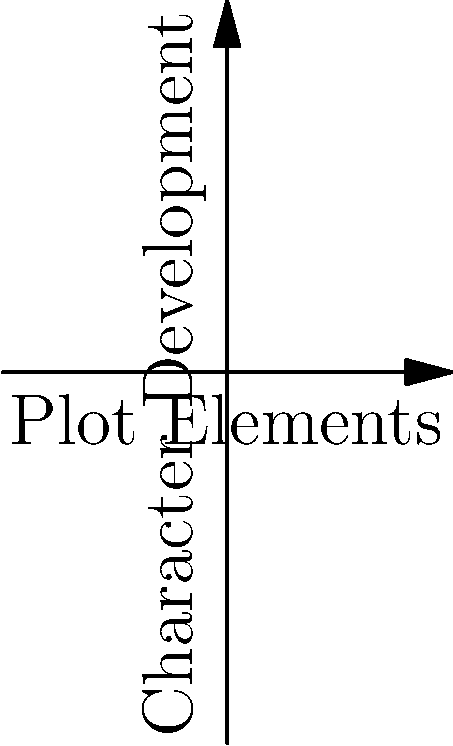In the diagram above, celestial bodies A, B, C, and D represent different plot elements in a reimagined narrative. The arrows between them represent gravitational forces influencing character development. If the gravitational force $F$ between two bodies is given by $F = \frac{GM_1M_2}{r^2}$, where $G$ is a constant, $M_1$ and $M_2$ are the masses of the bodies, and $r$ is the distance between them, how would the force between B and C compare to the force between A and B, assuming all bodies have equal mass? To compare the gravitational forces, we need to consider the distances between the celestial bodies, as the masses are assumed to be equal.

Step 1: Identify the relevant formula.
The gravitational force is given by $F = \frac{GM_1M_2}{r^2}$

Step 2: Simplify the formula for our scenario.
Since all masses are equal (let's call this mass M) and G is constant, we can simplify to:
$F \propto \frac{1}{r^2}$

Step 3: Calculate the distances.
Distance AB: $\sqrt{(2-1)^2 + (3-1)^2} = \sqrt{5}$
Distance BC: $\sqrt{(3-2)^2 + (2-3)^2} = \sqrt{2}$

Step 4: Compare the forces.
$F_{AB} \propto \frac{1}{(\sqrt{5})^2} = \frac{1}{5}$
$F_{BC} \propto \frac{1}{(\sqrt{2})^2} = \frac{1}{2}$

Step 5: Find the ratio of forces.
$\frac{F_{BC}}{F_{AB}} = \frac{\frac{1}{2}}{\frac{1}{5}} = \frac{5}{2} = 2.5$

Therefore, the force between B and C is 2.5 times stronger than the force between A and B.
Answer: 2.5 times stronger 